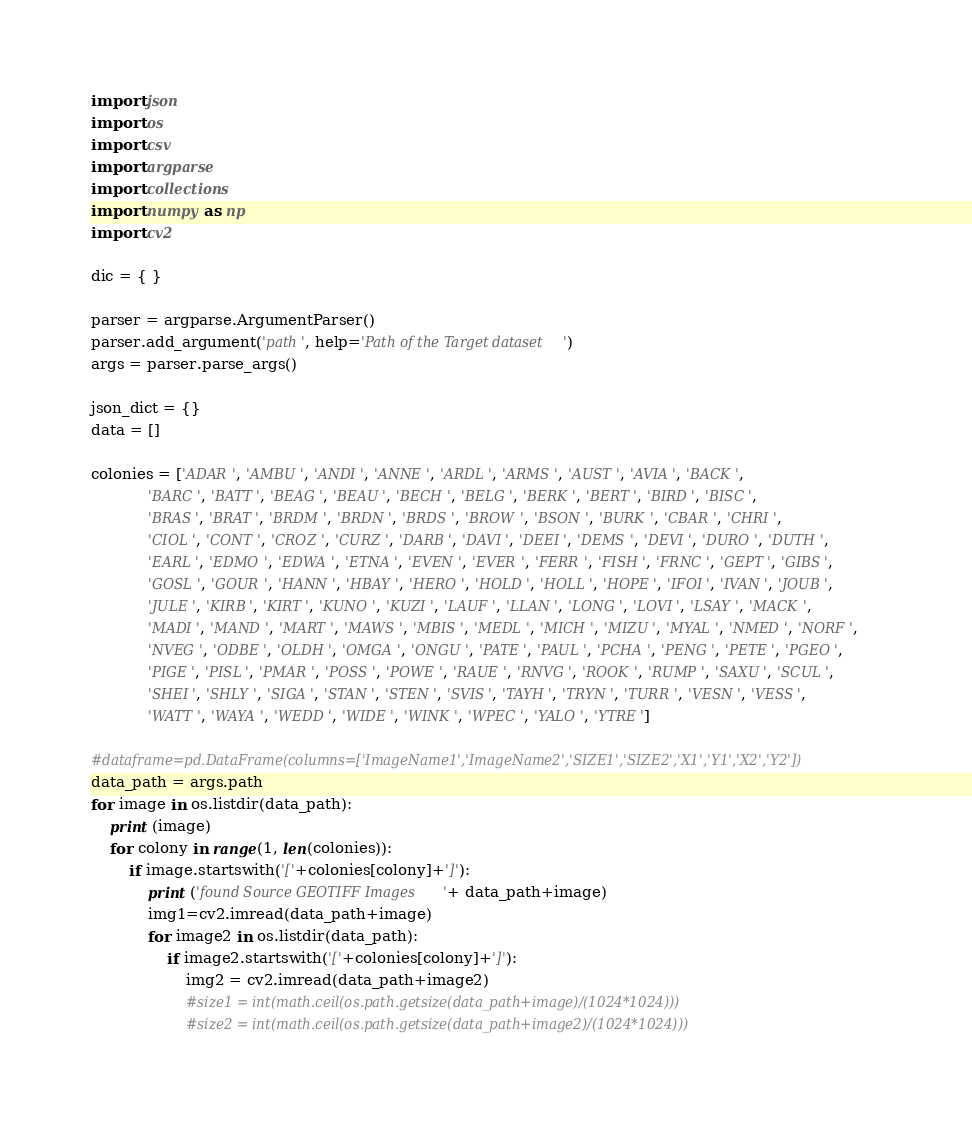<code> <loc_0><loc_0><loc_500><loc_500><_Python_>import json
import os
import csv
import argparse
import collections
import numpy as np
import cv2

dic = { }

parser = argparse.ArgumentParser()
parser.add_argument('path', help='Path of the Target dataset')
args = parser.parse_args()

json_dict = {}
data = []

colonies = ['ADAR', 'AMBU', 'ANDI', 'ANNE', 'ARDL', 'ARMS', 'AUST', 'AVIA', 'BACK',
            'BARC', 'BATT', 'BEAG', 'BEAU', 'BECH', 'BELG', 'BERK', 'BERT', 'BIRD', 'BISC',
            'BRAS', 'BRAT', 'BRDM', 'BRDN', 'BRDS', 'BROW', 'BSON', 'BURK', 'CBAR', 'CHRI',
            'CIOL', 'CONT', 'CROZ', 'CURZ', 'DARB', 'DAVI', 'DEEI', 'DEMS', 'DEVI', 'DURO', 'DUTH',
            'EARL', 'EDMO', 'EDWA', 'ETNA', 'EVEN', 'EVER', 'FERR', 'FISH', 'FRNC', 'GEPT', 'GIBS',
            'GOSL', 'GOUR', 'HANN', 'HBAY', 'HERO', 'HOLD', 'HOLL', 'HOPE', 'IFOI', 'IVAN', 'JOUB',
            'JULE', 'KIRB', 'KIRT', 'KUNO', 'KUZI', 'LAUF', 'LLAN', 'LONG', 'LOVI', 'LSAY', 'MACK',
            'MADI', 'MAND', 'MART', 'MAWS', 'MBIS', 'MEDL', 'MICH', 'MIZU', 'MYAL', 'NMED', 'NORF',
            'NVEG', 'ODBE', 'OLDH', 'OMGA', 'ONGU', 'PATE', 'PAUL', 'PCHA', 'PENG', 'PETE', 'PGEO',
            'PIGE', 'PISL', 'PMAR', 'POSS', 'POWE', 'RAUE', 'RNVG', 'ROOK', 'RUMP', 'SAXU', 'SCUL',
            'SHEI', 'SHLY', 'SIGA', 'STAN', 'STEN', 'SVIS', 'TAYH', 'TRYN', 'TURR', 'VESN', 'VESS',
            'WATT', 'WAYA', 'WEDD', 'WIDE', 'WINK', 'WPEC', 'YALO', 'YTRE']

#dataframe=pd.DataFrame(columns=['ImageName1','ImageName2','SIZE1','SIZE2','X1','Y1','X2','Y2'])
data_path = args.path
for image in os.listdir(data_path):
    print (image)
    for colony in range(1, len(colonies)):
        if image.startswith('['+colonies[colony]+']'):
            print ('found Source GEOTIFF Images '+ data_path+image)
            img1=cv2.imread(data_path+image)
            for image2 in os.listdir(data_path):
                if image2.startswith('['+colonies[colony]+']'):
                    img2 = cv2.imread(data_path+image2)
                    #size1 = int(math.ceil(os.path.getsize(data_path+image)/(1024*1024)))
                    #size2 = int(math.ceil(os.path.getsize(data_path+image2)/(1024*1024)))</code> 